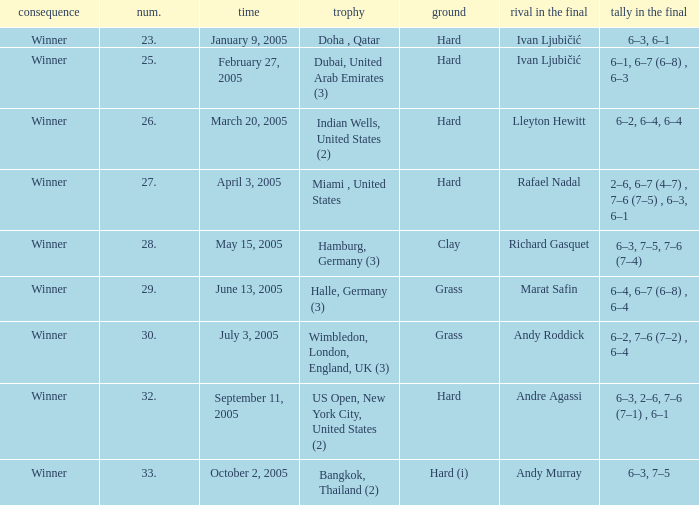Andy Roddick is the opponent in the final on what surface? Grass. 